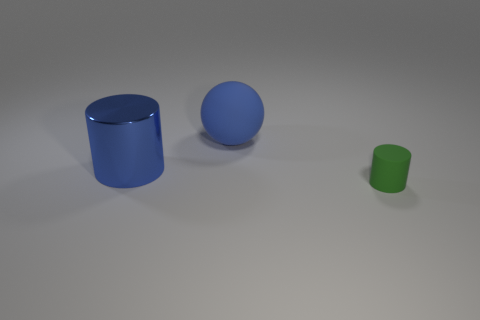What is the shape of the rubber object that is the same color as the large cylinder?
Make the answer very short. Sphere. Is there a big object that has the same material as the big cylinder?
Your answer should be very brief. No. Is the material of the blue thing in front of the large matte sphere the same as the cylinder that is to the right of the big blue sphere?
Your answer should be very brief. No. Are there the same number of large blue cylinders behind the large matte thing and large metal objects right of the small green object?
Provide a short and direct response. Yes. There is a matte sphere that is the same size as the blue metallic cylinder; what is its color?
Make the answer very short. Blue. Are there any large blocks that have the same color as the small matte thing?
Offer a terse response. No. What number of things are big blue things that are to the right of the big metal cylinder or green matte objects?
Offer a very short reply. 2. What number of other objects are there of the same size as the green matte thing?
Keep it short and to the point. 0. What is the material of the cylinder that is to the right of the cylinder that is on the left side of the matte object that is in front of the blue cylinder?
Give a very brief answer. Rubber. What number of blocks are either green objects or big blue rubber objects?
Your answer should be very brief. 0. 